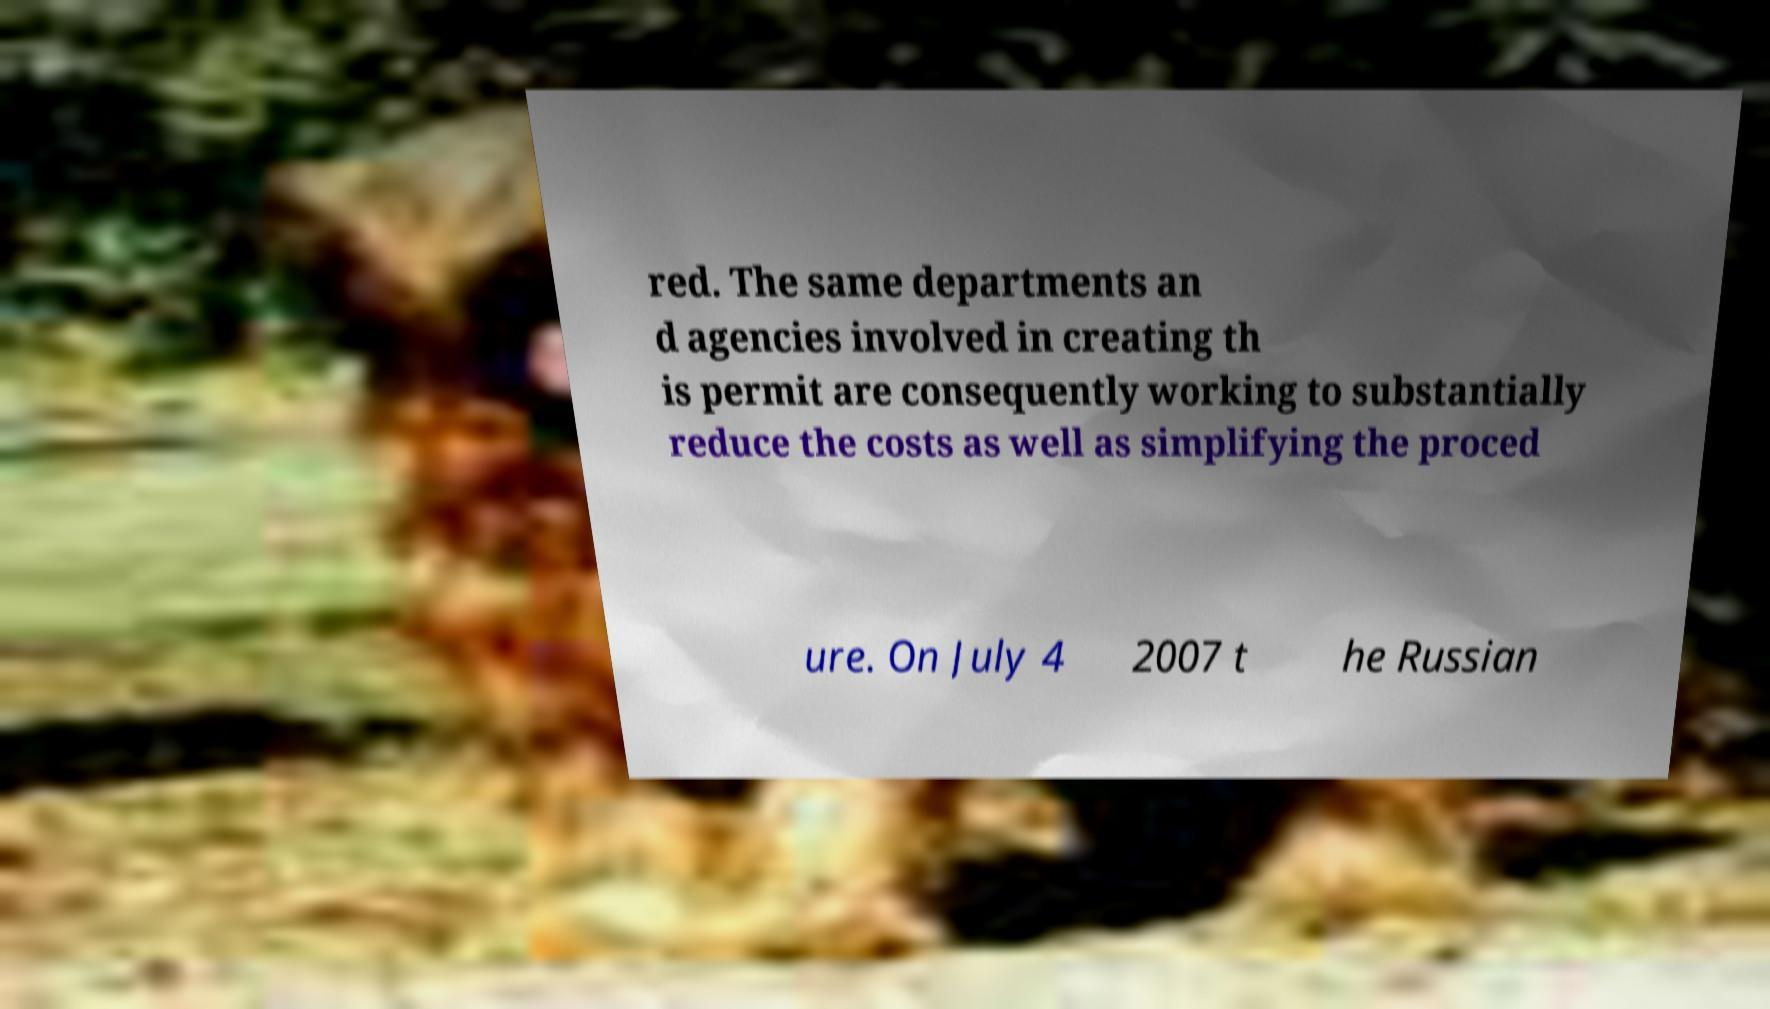Please identify and transcribe the text found in this image. red. The same departments an d agencies involved in creating th is permit are consequently working to substantially reduce the costs as well as simplifying the proced ure. On July 4 2007 t he Russian 